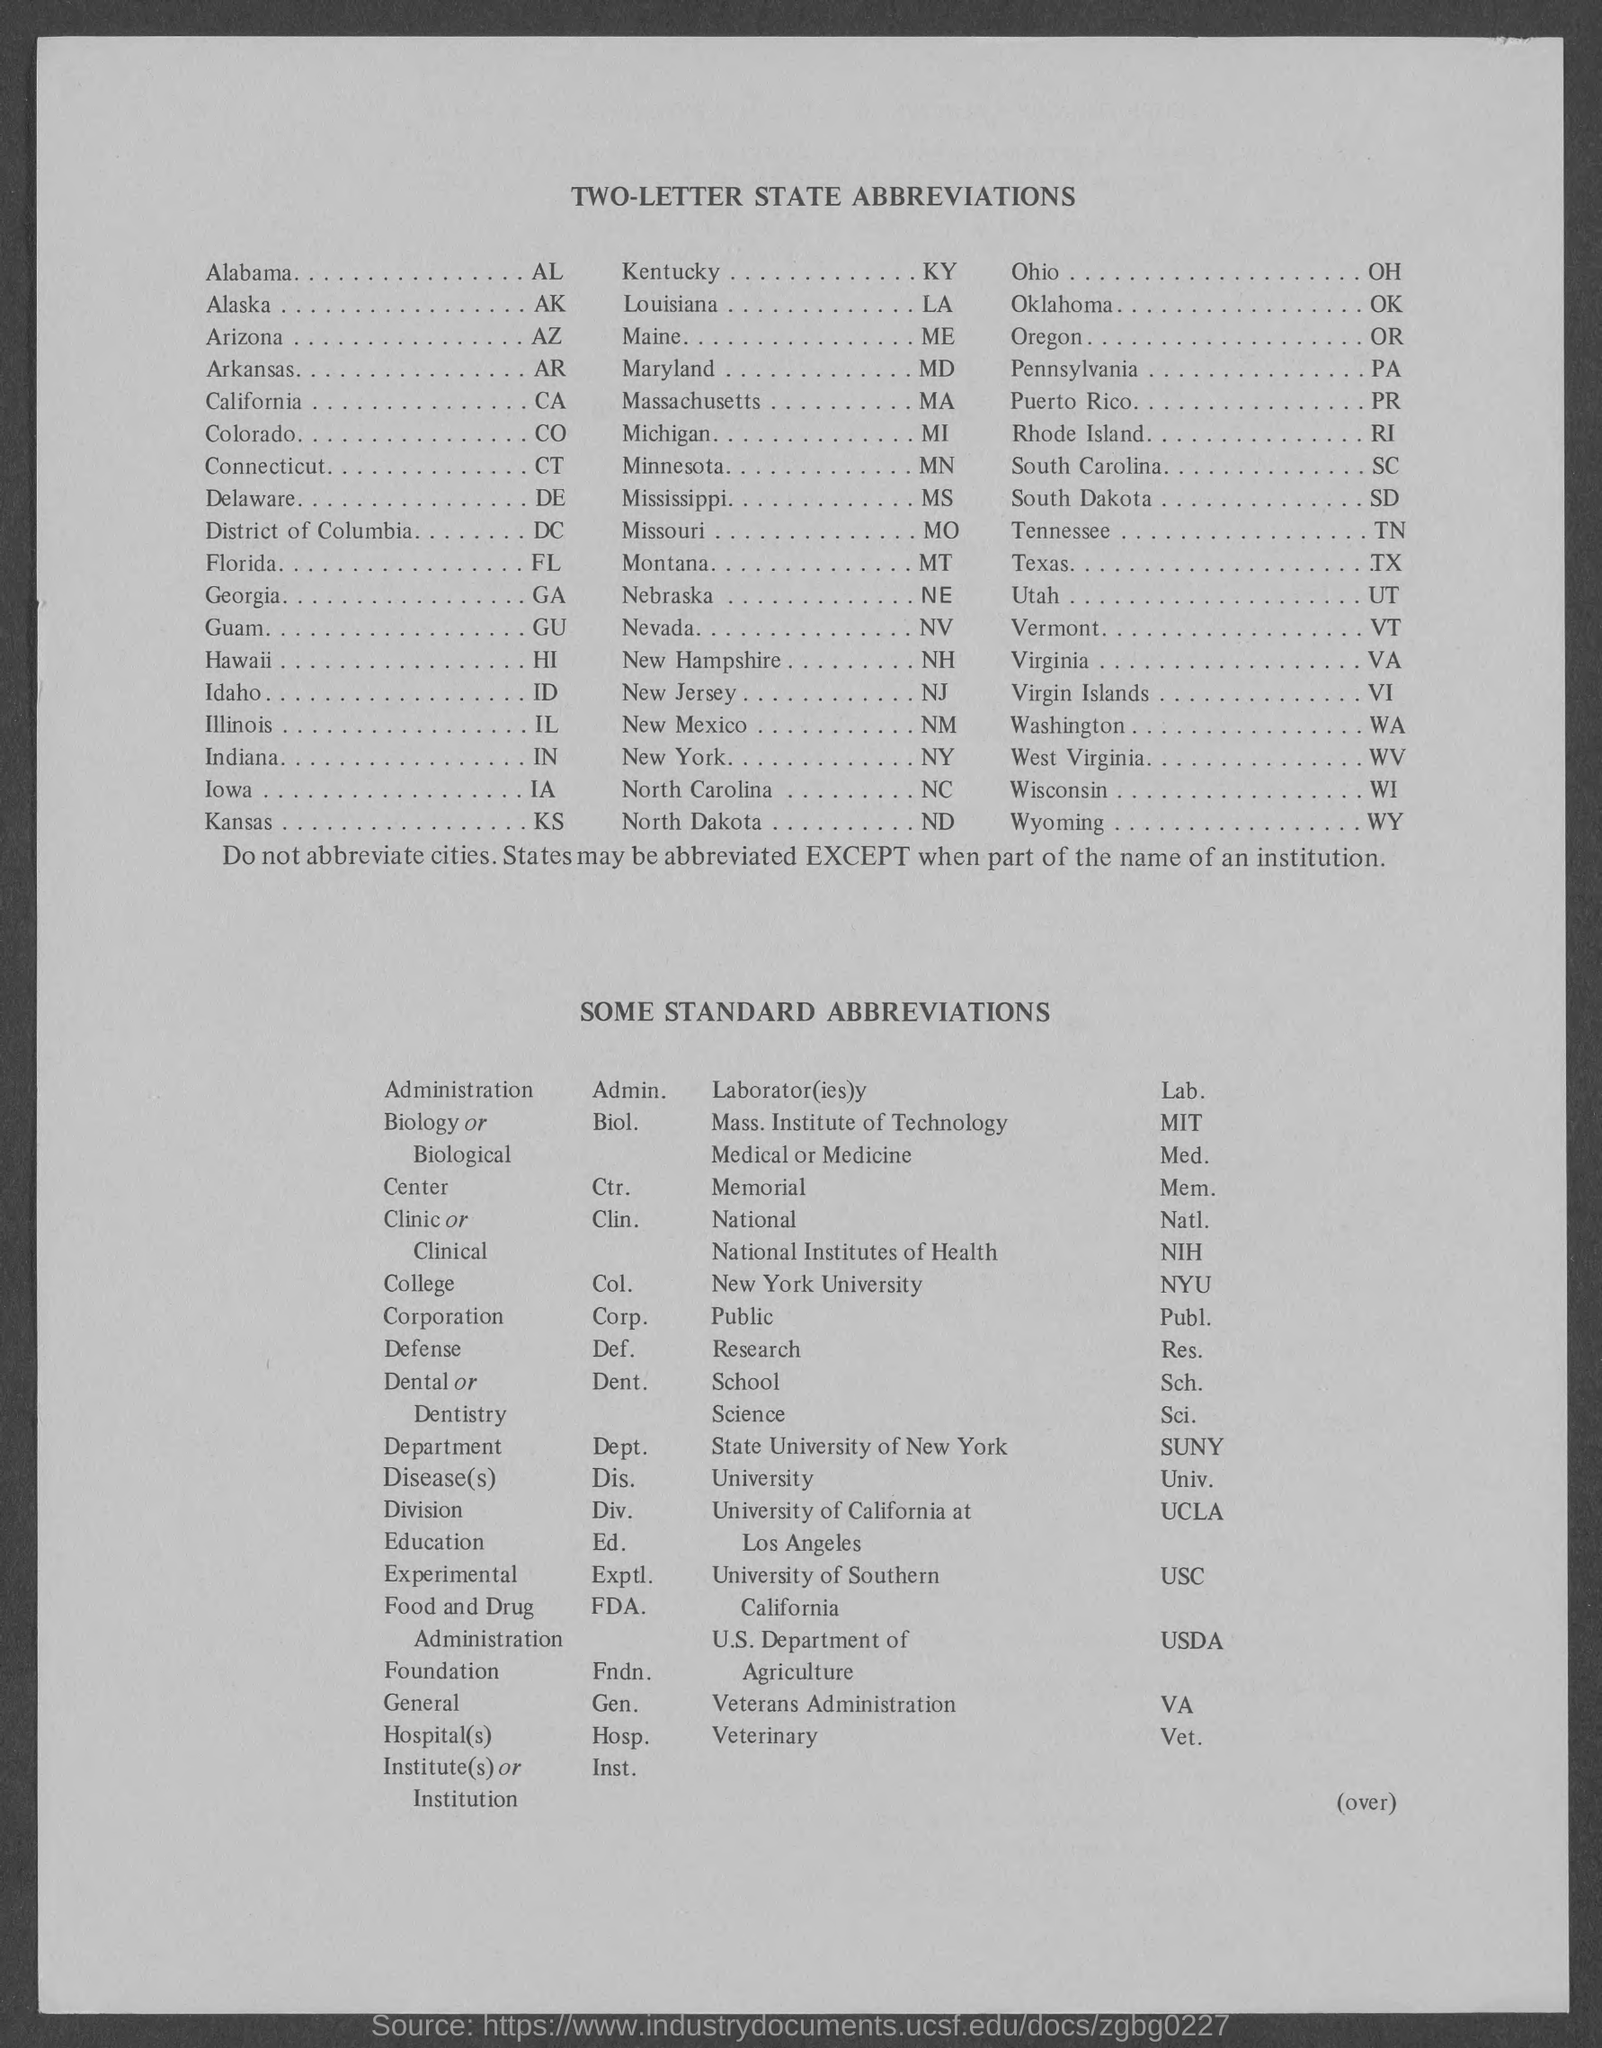Outline some significant characteristics in this image. The full form of NIH is the National Institutes of Health. These are a group of institutes and centers that are part of the United States Department of Health and Human Services, responsible for biomedical and behavioral research, and the National Institutes of Health is the primary federal agency responsible for supporting and conducting medical research in the United States. Administration is the act of managing a government or organization, typically by a group of people with a great deal of power. The abbreviation for administration is "Admin. New York University is abbreviated as NYU. The abbreviation for Alaska is AK. The fullform of FDA is the Food and Drug Administration, which is responsible for regulating and overseeing the safety and efficacy of food and drugs in the United States. 